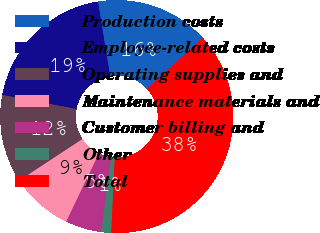<chart> <loc_0><loc_0><loc_500><loc_500><pie_chart><fcel>Production costs<fcel>Employee-related costs<fcel>Operating supplies and<fcel>Maintenance materials and<fcel>Customer billing and<fcel>Other<fcel>Total<nl><fcel>15.83%<fcel>19.44%<fcel>12.22%<fcel>8.61%<fcel>5.0%<fcel>1.39%<fcel>37.5%<nl></chart> 